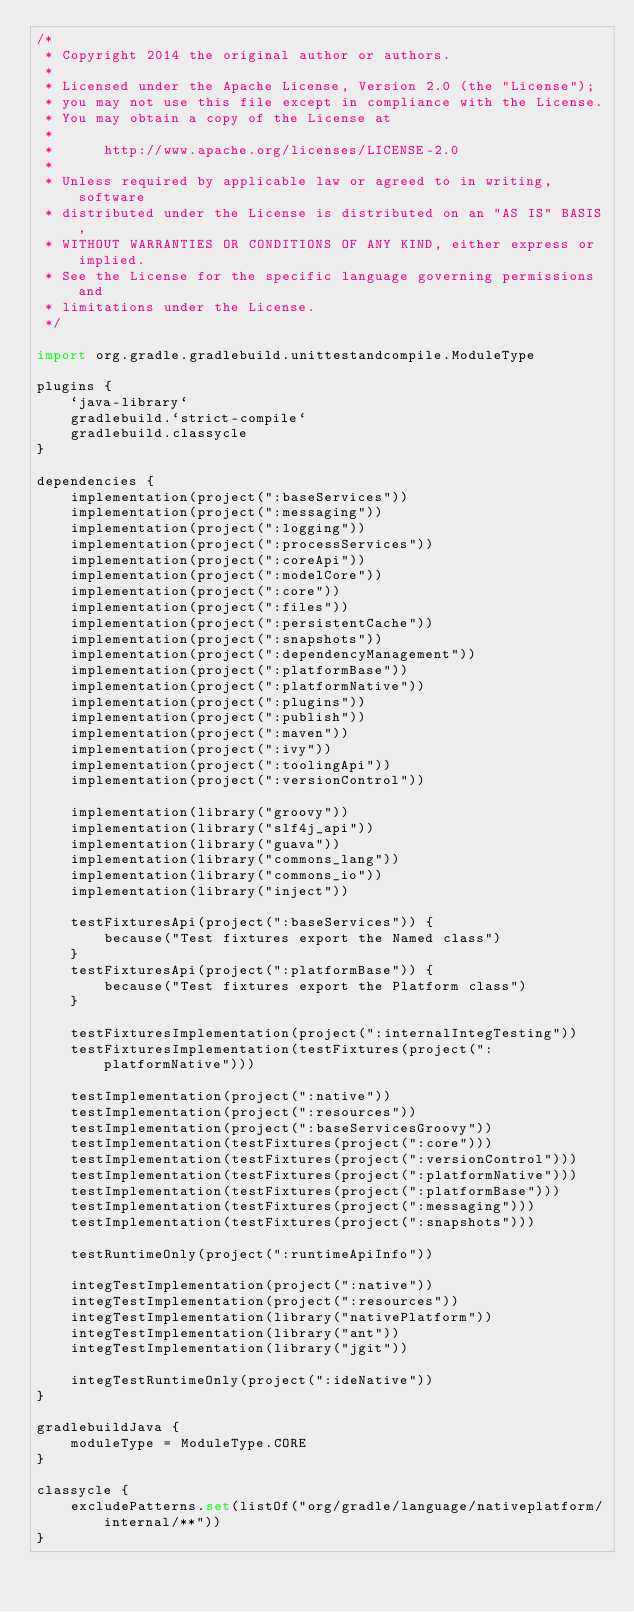Convert code to text. <code><loc_0><loc_0><loc_500><loc_500><_Kotlin_>/*
 * Copyright 2014 the original author or authors.
 *
 * Licensed under the Apache License, Version 2.0 (the "License");
 * you may not use this file except in compliance with the License.
 * You may obtain a copy of the License at
 *
 *      http://www.apache.org/licenses/LICENSE-2.0
 *
 * Unless required by applicable law or agreed to in writing, software
 * distributed under the License is distributed on an "AS IS" BASIS,
 * WITHOUT WARRANTIES OR CONDITIONS OF ANY KIND, either express or implied.
 * See the License for the specific language governing permissions and
 * limitations under the License.
 */

import org.gradle.gradlebuild.unittestandcompile.ModuleType

plugins {
    `java-library`
    gradlebuild.`strict-compile`
    gradlebuild.classycle
}

dependencies {
    implementation(project(":baseServices"))
    implementation(project(":messaging"))
    implementation(project(":logging"))
    implementation(project(":processServices"))
    implementation(project(":coreApi"))
    implementation(project(":modelCore"))
    implementation(project(":core"))
    implementation(project(":files"))
    implementation(project(":persistentCache"))
    implementation(project(":snapshots"))
    implementation(project(":dependencyManagement"))
    implementation(project(":platformBase"))
    implementation(project(":platformNative"))
    implementation(project(":plugins"))
    implementation(project(":publish"))
    implementation(project(":maven"))
    implementation(project(":ivy"))
    implementation(project(":toolingApi"))
    implementation(project(":versionControl"))

    implementation(library("groovy"))
    implementation(library("slf4j_api"))
    implementation(library("guava"))
    implementation(library("commons_lang"))
    implementation(library("commons_io"))
    implementation(library("inject"))

    testFixturesApi(project(":baseServices")) {
        because("Test fixtures export the Named class")
    }
    testFixturesApi(project(":platformBase")) {
        because("Test fixtures export the Platform class")
    }

    testFixturesImplementation(project(":internalIntegTesting"))
    testFixturesImplementation(testFixtures(project(":platformNative")))

    testImplementation(project(":native"))
    testImplementation(project(":resources"))
    testImplementation(project(":baseServicesGroovy"))
    testImplementation(testFixtures(project(":core")))
    testImplementation(testFixtures(project(":versionControl")))
    testImplementation(testFixtures(project(":platformNative")))
    testImplementation(testFixtures(project(":platformBase")))
    testImplementation(testFixtures(project(":messaging")))
    testImplementation(testFixtures(project(":snapshots")))

    testRuntimeOnly(project(":runtimeApiInfo"))

    integTestImplementation(project(":native"))
    integTestImplementation(project(":resources"))
    integTestImplementation(library("nativePlatform"))
    integTestImplementation(library("ant"))
    integTestImplementation(library("jgit"))

    integTestRuntimeOnly(project(":ideNative"))
}

gradlebuildJava {
    moduleType = ModuleType.CORE
}

classycle {
    excludePatterns.set(listOf("org/gradle/language/nativeplatform/internal/**"))
}
</code> 